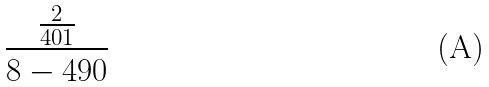Convert formula to latex. <formula><loc_0><loc_0><loc_500><loc_500>\frac { \frac { 2 } { 4 0 1 } } { 8 - 4 9 0 }</formula> 